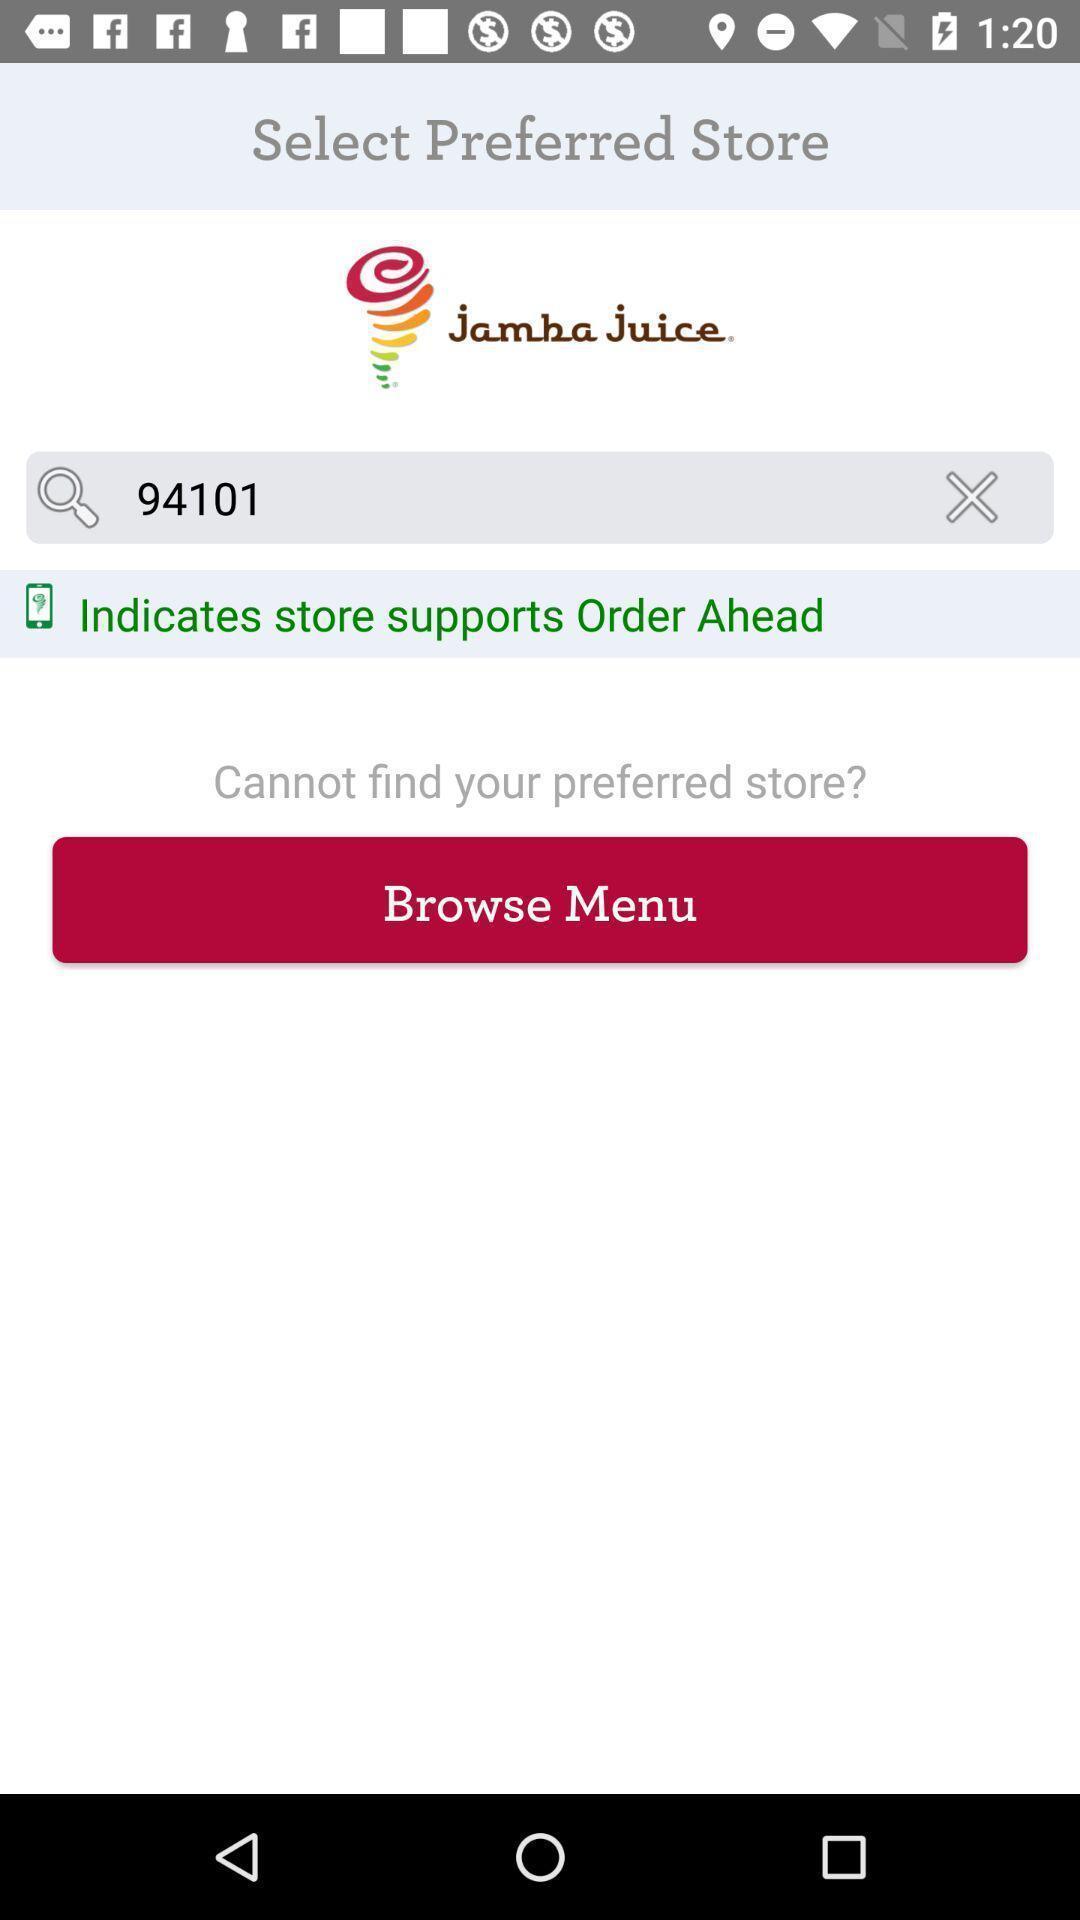Summarize the information in this screenshot. Page displaying to select the store in a food app. 